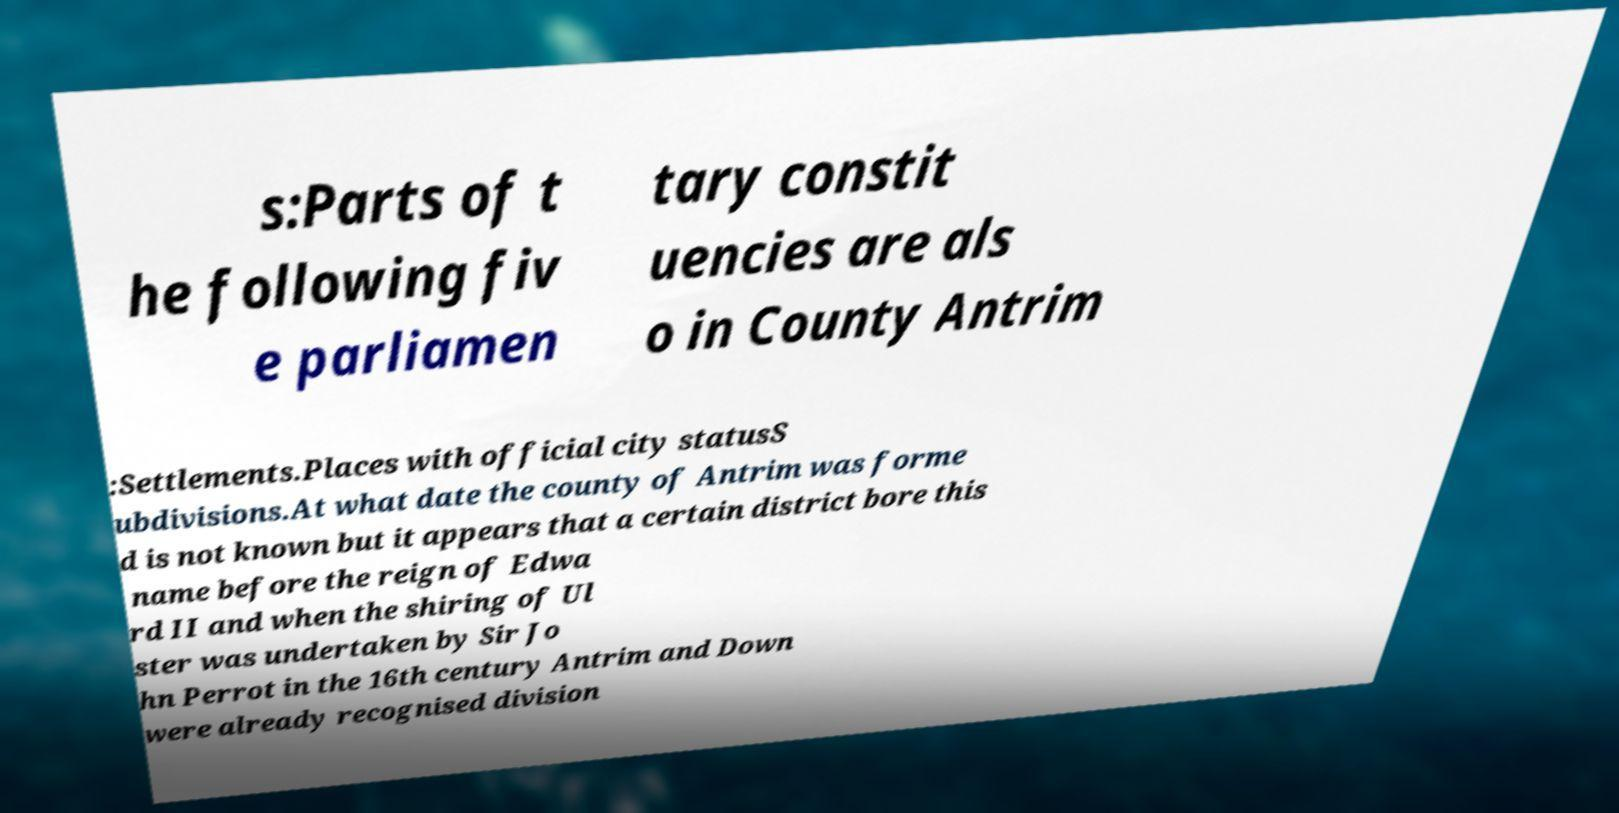Can you read and provide the text displayed in the image?This photo seems to have some interesting text. Can you extract and type it out for me? s:Parts of t he following fiv e parliamen tary constit uencies are als o in County Antrim :Settlements.Places with official city statusS ubdivisions.At what date the county of Antrim was forme d is not known but it appears that a certain district bore this name before the reign of Edwa rd II and when the shiring of Ul ster was undertaken by Sir Jo hn Perrot in the 16th century Antrim and Down were already recognised division 